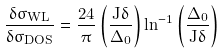<formula> <loc_0><loc_0><loc_500><loc_500>\frac { \delta \sigma _ { W L } } { \delta \sigma _ { D O S } } = \frac { 2 4 } { \pi } \left ( \frac { J \delta } { \Delta _ { 0 } } \right ) \ln ^ { - 1 } \left ( \frac { \Delta _ { 0 } } { J \delta } \right )</formula> 